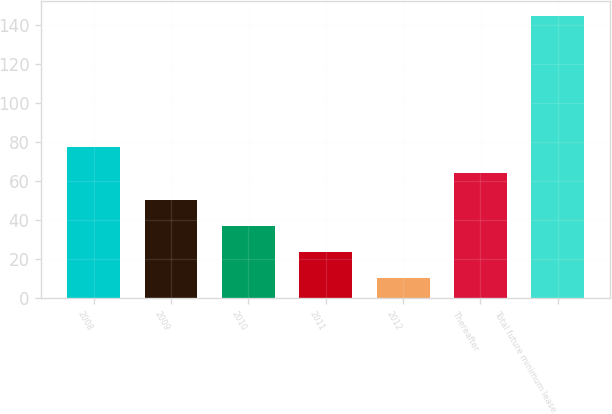Convert chart. <chart><loc_0><loc_0><loc_500><loc_500><bar_chart><fcel>2008<fcel>2009<fcel>2010<fcel>2011<fcel>2012<fcel>Thereafter<fcel>Total future minimum lease<nl><fcel>77.5<fcel>50.5<fcel>37<fcel>23.5<fcel>10<fcel>64<fcel>145<nl></chart> 